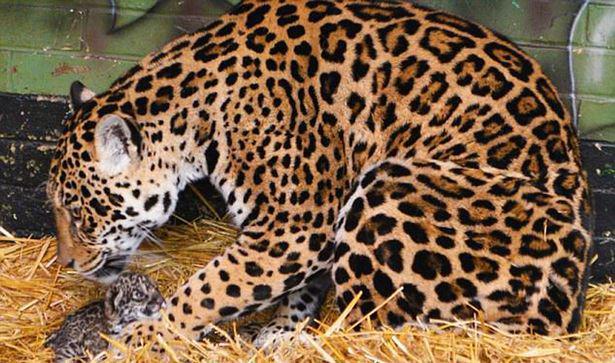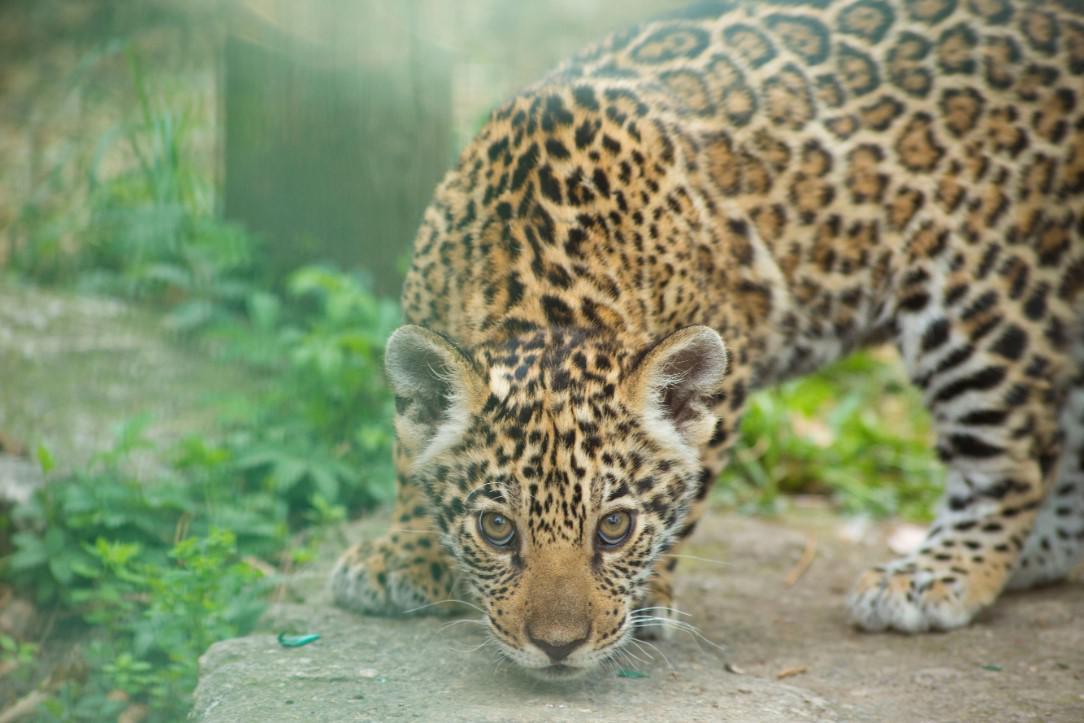The first image is the image on the left, the second image is the image on the right. For the images shown, is this caption "Both images have straw bedding." true? Answer yes or no. No. The first image is the image on the left, the second image is the image on the right. Given the left and right images, does the statement "Each image shows two leopards in an enclosure, and at least one image features an adult leopard with a young leopard kitten." hold true? Answer yes or no. No. 